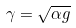<formula> <loc_0><loc_0><loc_500><loc_500>\gamma = \sqrt { \alpha g }</formula> 